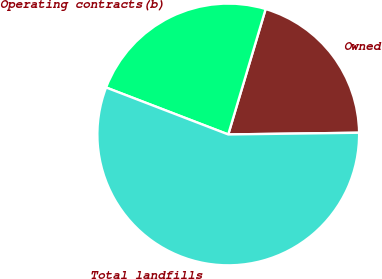Convert chart. <chart><loc_0><loc_0><loc_500><loc_500><pie_chart><fcel>Owned<fcel>Operating contracts(b)<fcel>Total landfills<nl><fcel>20.18%<fcel>23.77%<fcel>56.05%<nl></chart> 